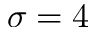Convert formula to latex. <formula><loc_0><loc_0><loc_500><loc_500>\sigma = 4</formula> 